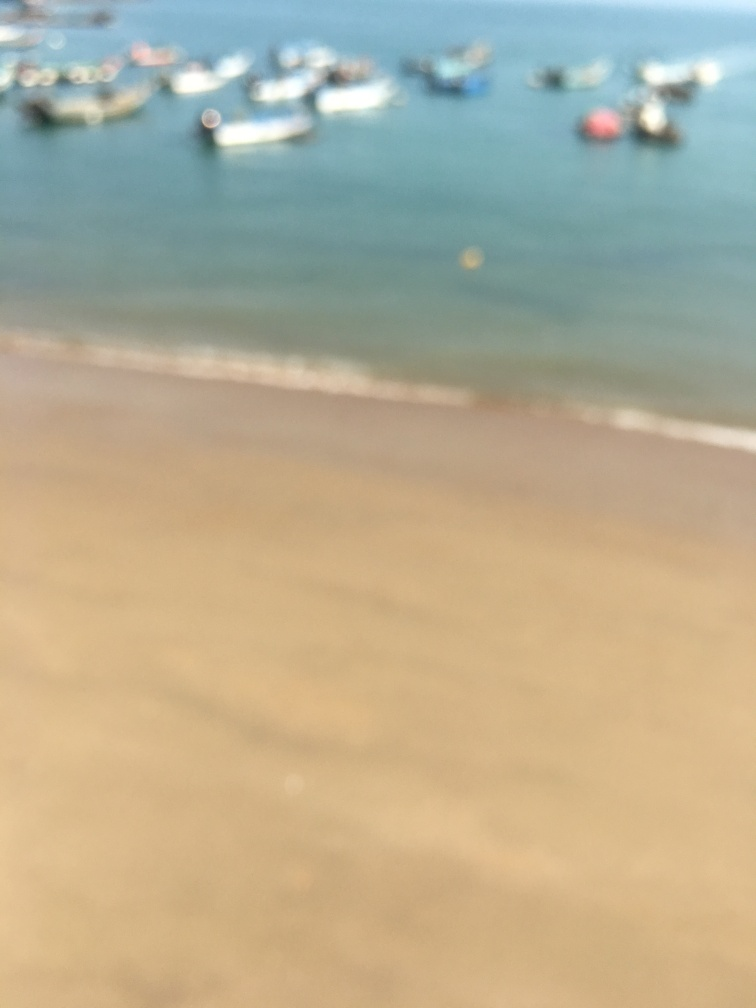What is the condition of the background?
A. Vividly colored
B. In focus
C. Clear and well-defined
D. Blurry and barely visible The background condition is most accurately described as D. Blurry and barely visible. The image shows an out-of-focus scene where specific details cannot be discerned. It appears to feature a beach and some boats on the water, but the lack of sharpness makes it difficult to identify any distinct features or colors clearly. 